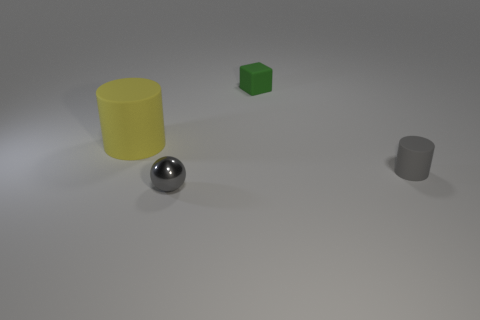What is the material of the tiny thing that is the same color as the metallic sphere?
Your response must be concise. Rubber. Is the material of the tiny cylinder the same as the large yellow thing?
Your answer should be very brief. Yes. What number of large objects are the same material as the gray ball?
Your response must be concise. 0. There is a cube that is the same material as the big cylinder; what is its color?
Offer a terse response. Green. The green object has what shape?
Offer a very short reply. Cube. There is a thing that is behind the large cylinder; what is it made of?
Offer a very short reply. Rubber. Are there any other tiny balls that have the same color as the metal sphere?
Ensure brevity in your answer.  No. What is the shape of the matte object that is the same size as the gray cylinder?
Your response must be concise. Cube. The cylinder in front of the big yellow rubber thing is what color?
Provide a succinct answer. Gray. There is a gray object that is right of the cube; are there any green blocks behind it?
Keep it short and to the point. Yes. 